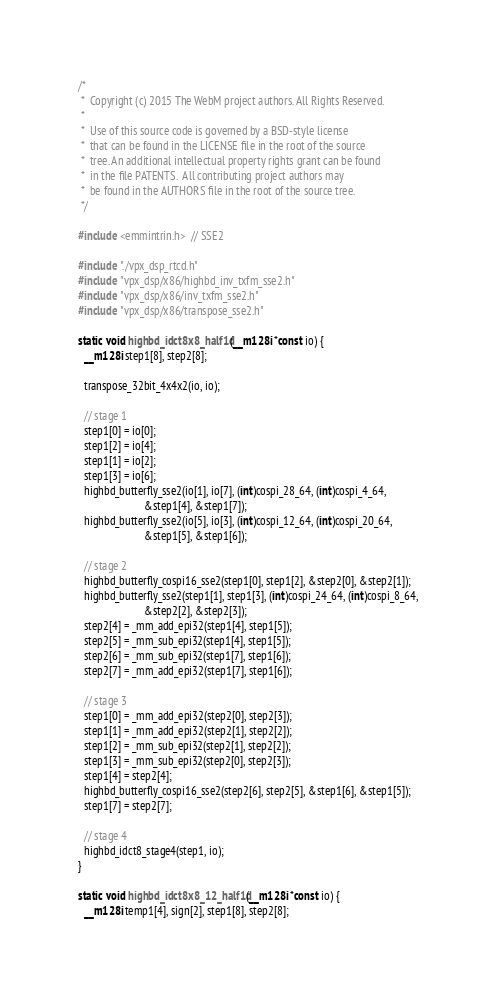<code> <loc_0><loc_0><loc_500><loc_500><_C_>/*
 *  Copyright (c) 2015 The WebM project authors. All Rights Reserved.
 *
 *  Use of this source code is governed by a BSD-style license
 *  that can be found in the LICENSE file in the root of the source
 *  tree. An additional intellectual property rights grant can be found
 *  in the file PATENTS.  All contributing project authors may
 *  be found in the AUTHORS file in the root of the source tree.
 */

#include <emmintrin.h>  // SSE2

#include "./vpx_dsp_rtcd.h"
#include "vpx_dsp/x86/highbd_inv_txfm_sse2.h"
#include "vpx_dsp/x86/inv_txfm_sse2.h"
#include "vpx_dsp/x86/transpose_sse2.h"

static void highbd_idct8x8_half1d(__m128i *const io) {
  __m128i step1[8], step2[8];

  transpose_32bit_4x4x2(io, io);

  // stage 1
  step1[0] = io[0];
  step1[2] = io[4];
  step1[1] = io[2];
  step1[3] = io[6];
  highbd_butterfly_sse2(io[1], io[7], (int)cospi_28_64, (int)cospi_4_64,
                        &step1[4], &step1[7]);
  highbd_butterfly_sse2(io[5], io[3], (int)cospi_12_64, (int)cospi_20_64,
                        &step1[5], &step1[6]);

  // stage 2
  highbd_butterfly_cospi16_sse2(step1[0], step1[2], &step2[0], &step2[1]);
  highbd_butterfly_sse2(step1[1], step1[3], (int)cospi_24_64, (int)cospi_8_64,
                        &step2[2], &step2[3]);
  step2[4] = _mm_add_epi32(step1[4], step1[5]);
  step2[5] = _mm_sub_epi32(step1[4], step1[5]);
  step2[6] = _mm_sub_epi32(step1[7], step1[6]);
  step2[7] = _mm_add_epi32(step1[7], step1[6]);

  // stage 3
  step1[0] = _mm_add_epi32(step2[0], step2[3]);
  step1[1] = _mm_add_epi32(step2[1], step2[2]);
  step1[2] = _mm_sub_epi32(step2[1], step2[2]);
  step1[3] = _mm_sub_epi32(step2[0], step2[3]);
  step1[4] = step2[4];
  highbd_butterfly_cospi16_sse2(step2[6], step2[5], &step1[6], &step1[5]);
  step1[7] = step2[7];

  // stage 4
  highbd_idct8_stage4(step1, io);
}

static void highbd_idct8x8_12_half1d(__m128i *const io) {
  __m128i temp1[4], sign[2], step1[8], step2[8];
</code> 